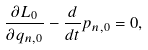Convert formula to latex. <formula><loc_0><loc_0><loc_500><loc_500>\frac { \partial L _ { 0 } } { \partial q _ { n , 0 } } - \frac { d } { d t } p _ { n , 0 } = 0 ,</formula> 